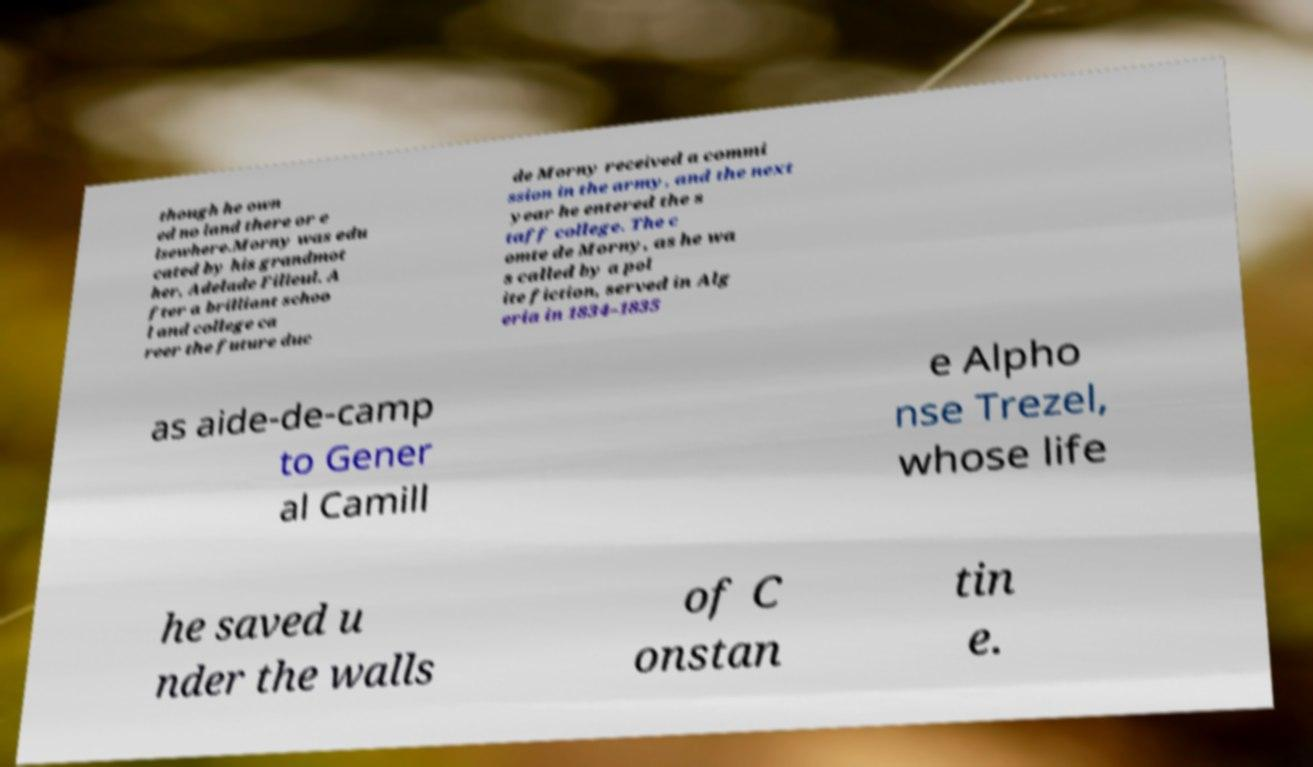I need the written content from this picture converted into text. Can you do that? though he own ed no land there or e lsewhere.Morny was edu cated by his grandmot her, Adelade Filleul. A fter a brilliant schoo l and college ca reer the future duc de Morny received a commi ssion in the army, and the next year he entered the s taff college. The c omte de Morny, as he wa s called by a pol ite fiction, served in Alg eria in 1834–1835 as aide-de-camp to Gener al Camill e Alpho nse Trezel, whose life he saved u nder the walls of C onstan tin e. 